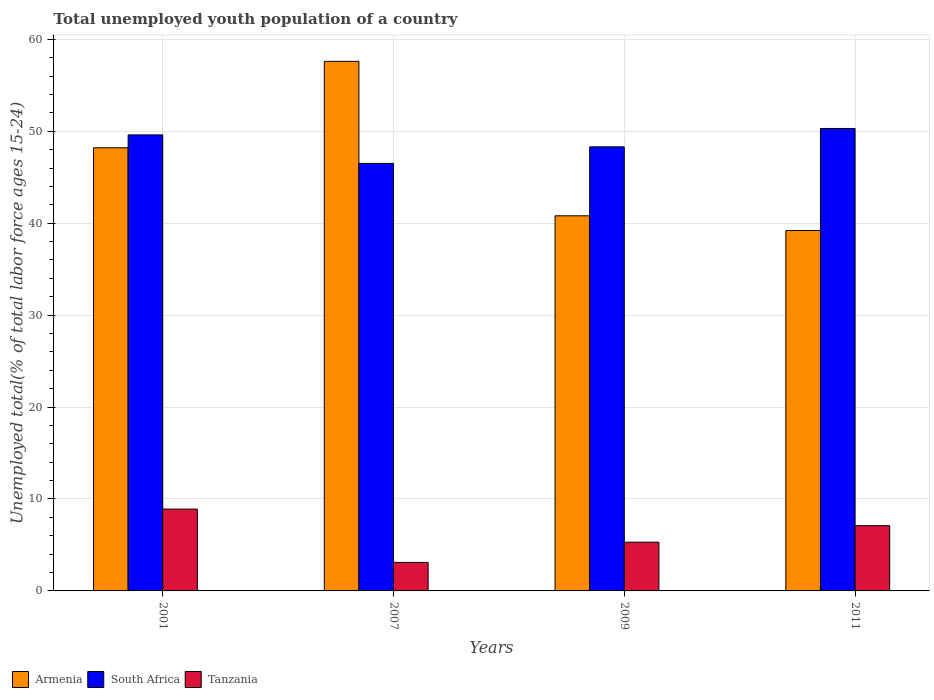How many different coloured bars are there?
Offer a terse response. 3. How many groups of bars are there?
Your answer should be very brief. 4. Are the number of bars on each tick of the X-axis equal?
Your answer should be very brief. Yes. How many bars are there on the 3rd tick from the right?
Make the answer very short. 3. What is the label of the 4th group of bars from the left?
Your answer should be compact. 2011. What is the percentage of total unemployed youth population of a country in South Africa in 2009?
Your answer should be very brief. 48.3. Across all years, what is the maximum percentage of total unemployed youth population of a country in South Africa?
Provide a short and direct response. 50.3. Across all years, what is the minimum percentage of total unemployed youth population of a country in South Africa?
Your answer should be compact. 46.5. What is the total percentage of total unemployed youth population of a country in South Africa in the graph?
Make the answer very short. 194.7. What is the difference between the percentage of total unemployed youth population of a country in Armenia in 2009 and that in 2011?
Give a very brief answer. 1.6. What is the difference between the percentage of total unemployed youth population of a country in Tanzania in 2011 and the percentage of total unemployed youth population of a country in South Africa in 2001?
Ensure brevity in your answer.  -42.5. What is the average percentage of total unemployed youth population of a country in South Africa per year?
Provide a short and direct response. 48.67. In the year 2007, what is the difference between the percentage of total unemployed youth population of a country in Tanzania and percentage of total unemployed youth population of a country in Armenia?
Your answer should be very brief. -54.5. What is the ratio of the percentage of total unemployed youth population of a country in South Africa in 2009 to that in 2011?
Make the answer very short. 0.96. Is the percentage of total unemployed youth population of a country in Armenia in 2001 less than that in 2009?
Give a very brief answer. No. Is the difference between the percentage of total unemployed youth population of a country in Tanzania in 2001 and 2011 greater than the difference between the percentage of total unemployed youth population of a country in Armenia in 2001 and 2011?
Your response must be concise. No. What is the difference between the highest and the second highest percentage of total unemployed youth population of a country in Armenia?
Offer a terse response. 9.4. What is the difference between the highest and the lowest percentage of total unemployed youth population of a country in South Africa?
Provide a succinct answer. 3.8. What does the 1st bar from the left in 2001 represents?
Your answer should be very brief. Armenia. What does the 3rd bar from the right in 2001 represents?
Offer a terse response. Armenia. Are all the bars in the graph horizontal?
Your answer should be compact. No. How many years are there in the graph?
Your response must be concise. 4. Does the graph contain any zero values?
Keep it short and to the point. No. Does the graph contain grids?
Ensure brevity in your answer.  Yes. Where does the legend appear in the graph?
Provide a short and direct response. Bottom left. What is the title of the graph?
Your response must be concise. Total unemployed youth population of a country. Does "Colombia" appear as one of the legend labels in the graph?
Offer a terse response. No. What is the label or title of the X-axis?
Provide a succinct answer. Years. What is the label or title of the Y-axis?
Give a very brief answer. Unemployed total(% of total labor force ages 15-24). What is the Unemployed total(% of total labor force ages 15-24) in Armenia in 2001?
Your response must be concise. 48.2. What is the Unemployed total(% of total labor force ages 15-24) of South Africa in 2001?
Your response must be concise. 49.6. What is the Unemployed total(% of total labor force ages 15-24) of Tanzania in 2001?
Your answer should be compact. 8.9. What is the Unemployed total(% of total labor force ages 15-24) in Armenia in 2007?
Ensure brevity in your answer.  57.6. What is the Unemployed total(% of total labor force ages 15-24) in South Africa in 2007?
Your response must be concise. 46.5. What is the Unemployed total(% of total labor force ages 15-24) of Tanzania in 2007?
Make the answer very short. 3.1. What is the Unemployed total(% of total labor force ages 15-24) in Armenia in 2009?
Your answer should be very brief. 40.8. What is the Unemployed total(% of total labor force ages 15-24) of South Africa in 2009?
Offer a very short reply. 48.3. What is the Unemployed total(% of total labor force ages 15-24) of Tanzania in 2009?
Provide a short and direct response. 5.3. What is the Unemployed total(% of total labor force ages 15-24) in Armenia in 2011?
Keep it short and to the point. 39.2. What is the Unemployed total(% of total labor force ages 15-24) in South Africa in 2011?
Your answer should be compact. 50.3. What is the Unemployed total(% of total labor force ages 15-24) in Tanzania in 2011?
Offer a very short reply. 7.1. Across all years, what is the maximum Unemployed total(% of total labor force ages 15-24) of Armenia?
Ensure brevity in your answer.  57.6. Across all years, what is the maximum Unemployed total(% of total labor force ages 15-24) of South Africa?
Your answer should be very brief. 50.3. Across all years, what is the maximum Unemployed total(% of total labor force ages 15-24) of Tanzania?
Make the answer very short. 8.9. Across all years, what is the minimum Unemployed total(% of total labor force ages 15-24) in Armenia?
Keep it short and to the point. 39.2. Across all years, what is the minimum Unemployed total(% of total labor force ages 15-24) in South Africa?
Provide a succinct answer. 46.5. Across all years, what is the minimum Unemployed total(% of total labor force ages 15-24) of Tanzania?
Give a very brief answer. 3.1. What is the total Unemployed total(% of total labor force ages 15-24) in Armenia in the graph?
Provide a succinct answer. 185.8. What is the total Unemployed total(% of total labor force ages 15-24) in South Africa in the graph?
Keep it short and to the point. 194.7. What is the total Unemployed total(% of total labor force ages 15-24) of Tanzania in the graph?
Keep it short and to the point. 24.4. What is the difference between the Unemployed total(% of total labor force ages 15-24) in Armenia in 2001 and that in 2007?
Offer a terse response. -9.4. What is the difference between the Unemployed total(% of total labor force ages 15-24) in Tanzania in 2001 and that in 2011?
Provide a succinct answer. 1.8. What is the difference between the Unemployed total(% of total labor force ages 15-24) in South Africa in 2007 and that in 2009?
Offer a terse response. -1.8. What is the difference between the Unemployed total(% of total labor force ages 15-24) in Tanzania in 2007 and that in 2009?
Your response must be concise. -2.2. What is the difference between the Unemployed total(% of total labor force ages 15-24) of Armenia in 2007 and that in 2011?
Provide a succinct answer. 18.4. What is the difference between the Unemployed total(% of total labor force ages 15-24) of Tanzania in 2007 and that in 2011?
Make the answer very short. -4. What is the difference between the Unemployed total(% of total labor force ages 15-24) in Armenia in 2009 and that in 2011?
Offer a very short reply. 1.6. What is the difference between the Unemployed total(% of total labor force ages 15-24) of Armenia in 2001 and the Unemployed total(% of total labor force ages 15-24) of Tanzania in 2007?
Your response must be concise. 45.1. What is the difference between the Unemployed total(% of total labor force ages 15-24) of South Africa in 2001 and the Unemployed total(% of total labor force ages 15-24) of Tanzania in 2007?
Your answer should be compact. 46.5. What is the difference between the Unemployed total(% of total labor force ages 15-24) in Armenia in 2001 and the Unemployed total(% of total labor force ages 15-24) in South Africa in 2009?
Provide a short and direct response. -0.1. What is the difference between the Unemployed total(% of total labor force ages 15-24) of Armenia in 2001 and the Unemployed total(% of total labor force ages 15-24) of Tanzania in 2009?
Make the answer very short. 42.9. What is the difference between the Unemployed total(% of total labor force ages 15-24) in South Africa in 2001 and the Unemployed total(% of total labor force ages 15-24) in Tanzania in 2009?
Offer a very short reply. 44.3. What is the difference between the Unemployed total(% of total labor force ages 15-24) in Armenia in 2001 and the Unemployed total(% of total labor force ages 15-24) in South Africa in 2011?
Your response must be concise. -2.1. What is the difference between the Unemployed total(% of total labor force ages 15-24) of Armenia in 2001 and the Unemployed total(% of total labor force ages 15-24) of Tanzania in 2011?
Your answer should be very brief. 41.1. What is the difference between the Unemployed total(% of total labor force ages 15-24) in South Africa in 2001 and the Unemployed total(% of total labor force ages 15-24) in Tanzania in 2011?
Offer a very short reply. 42.5. What is the difference between the Unemployed total(% of total labor force ages 15-24) of Armenia in 2007 and the Unemployed total(% of total labor force ages 15-24) of South Africa in 2009?
Provide a succinct answer. 9.3. What is the difference between the Unemployed total(% of total labor force ages 15-24) of Armenia in 2007 and the Unemployed total(% of total labor force ages 15-24) of Tanzania in 2009?
Provide a short and direct response. 52.3. What is the difference between the Unemployed total(% of total labor force ages 15-24) of South Africa in 2007 and the Unemployed total(% of total labor force ages 15-24) of Tanzania in 2009?
Your answer should be compact. 41.2. What is the difference between the Unemployed total(% of total labor force ages 15-24) of Armenia in 2007 and the Unemployed total(% of total labor force ages 15-24) of Tanzania in 2011?
Ensure brevity in your answer.  50.5. What is the difference between the Unemployed total(% of total labor force ages 15-24) of South Africa in 2007 and the Unemployed total(% of total labor force ages 15-24) of Tanzania in 2011?
Offer a very short reply. 39.4. What is the difference between the Unemployed total(% of total labor force ages 15-24) of Armenia in 2009 and the Unemployed total(% of total labor force ages 15-24) of Tanzania in 2011?
Offer a terse response. 33.7. What is the difference between the Unemployed total(% of total labor force ages 15-24) of South Africa in 2009 and the Unemployed total(% of total labor force ages 15-24) of Tanzania in 2011?
Provide a short and direct response. 41.2. What is the average Unemployed total(% of total labor force ages 15-24) in Armenia per year?
Keep it short and to the point. 46.45. What is the average Unemployed total(% of total labor force ages 15-24) in South Africa per year?
Make the answer very short. 48.67. What is the average Unemployed total(% of total labor force ages 15-24) of Tanzania per year?
Provide a short and direct response. 6.1. In the year 2001, what is the difference between the Unemployed total(% of total labor force ages 15-24) of Armenia and Unemployed total(% of total labor force ages 15-24) of Tanzania?
Give a very brief answer. 39.3. In the year 2001, what is the difference between the Unemployed total(% of total labor force ages 15-24) in South Africa and Unemployed total(% of total labor force ages 15-24) in Tanzania?
Ensure brevity in your answer.  40.7. In the year 2007, what is the difference between the Unemployed total(% of total labor force ages 15-24) in Armenia and Unemployed total(% of total labor force ages 15-24) in Tanzania?
Make the answer very short. 54.5. In the year 2007, what is the difference between the Unemployed total(% of total labor force ages 15-24) in South Africa and Unemployed total(% of total labor force ages 15-24) in Tanzania?
Give a very brief answer. 43.4. In the year 2009, what is the difference between the Unemployed total(% of total labor force ages 15-24) in Armenia and Unemployed total(% of total labor force ages 15-24) in Tanzania?
Make the answer very short. 35.5. In the year 2009, what is the difference between the Unemployed total(% of total labor force ages 15-24) of South Africa and Unemployed total(% of total labor force ages 15-24) of Tanzania?
Keep it short and to the point. 43. In the year 2011, what is the difference between the Unemployed total(% of total labor force ages 15-24) in Armenia and Unemployed total(% of total labor force ages 15-24) in Tanzania?
Ensure brevity in your answer.  32.1. In the year 2011, what is the difference between the Unemployed total(% of total labor force ages 15-24) in South Africa and Unemployed total(% of total labor force ages 15-24) in Tanzania?
Offer a terse response. 43.2. What is the ratio of the Unemployed total(% of total labor force ages 15-24) of Armenia in 2001 to that in 2007?
Your response must be concise. 0.84. What is the ratio of the Unemployed total(% of total labor force ages 15-24) in South Africa in 2001 to that in 2007?
Offer a terse response. 1.07. What is the ratio of the Unemployed total(% of total labor force ages 15-24) in Tanzania in 2001 to that in 2007?
Your answer should be compact. 2.87. What is the ratio of the Unemployed total(% of total labor force ages 15-24) in Armenia in 2001 to that in 2009?
Make the answer very short. 1.18. What is the ratio of the Unemployed total(% of total labor force ages 15-24) in South Africa in 2001 to that in 2009?
Make the answer very short. 1.03. What is the ratio of the Unemployed total(% of total labor force ages 15-24) of Tanzania in 2001 to that in 2009?
Offer a very short reply. 1.68. What is the ratio of the Unemployed total(% of total labor force ages 15-24) in Armenia in 2001 to that in 2011?
Make the answer very short. 1.23. What is the ratio of the Unemployed total(% of total labor force ages 15-24) of South Africa in 2001 to that in 2011?
Keep it short and to the point. 0.99. What is the ratio of the Unemployed total(% of total labor force ages 15-24) of Tanzania in 2001 to that in 2011?
Offer a very short reply. 1.25. What is the ratio of the Unemployed total(% of total labor force ages 15-24) of Armenia in 2007 to that in 2009?
Provide a succinct answer. 1.41. What is the ratio of the Unemployed total(% of total labor force ages 15-24) in South Africa in 2007 to that in 2009?
Keep it short and to the point. 0.96. What is the ratio of the Unemployed total(% of total labor force ages 15-24) in Tanzania in 2007 to that in 2009?
Make the answer very short. 0.58. What is the ratio of the Unemployed total(% of total labor force ages 15-24) of Armenia in 2007 to that in 2011?
Provide a succinct answer. 1.47. What is the ratio of the Unemployed total(% of total labor force ages 15-24) in South Africa in 2007 to that in 2011?
Offer a very short reply. 0.92. What is the ratio of the Unemployed total(% of total labor force ages 15-24) of Tanzania in 2007 to that in 2011?
Your response must be concise. 0.44. What is the ratio of the Unemployed total(% of total labor force ages 15-24) of Armenia in 2009 to that in 2011?
Make the answer very short. 1.04. What is the ratio of the Unemployed total(% of total labor force ages 15-24) in South Africa in 2009 to that in 2011?
Make the answer very short. 0.96. What is the ratio of the Unemployed total(% of total labor force ages 15-24) of Tanzania in 2009 to that in 2011?
Offer a very short reply. 0.75. What is the difference between the highest and the second highest Unemployed total(% of total labor force ages 15-24) in Armenia?
Your answer should be very brief. 9.4. What is the difference between the highest and the second highest Unemployed total(% of total labor force ages 15-24) in South Africa?
Provide a short and direct response. 0.7. What is the difference between the highest and the lowest Unemployed total(% of total labor force ages 15-24) in South Africa?
Ensure brevity in your answer.  3.8. What is the difference between the highest and the lowest Unemployed total(% of total labor force ages 15-24) of Tanzania?
Your answer should be compact. 5.8. 